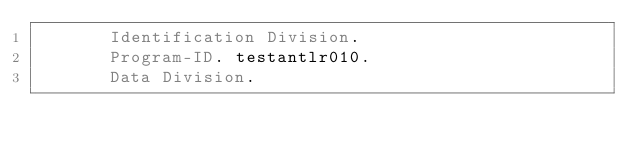<code> <loc_0><loc_0><loc_500><loc_500><_COBOL_>       Identification Division.
       Program-ID. testantlr010.
       Data Division.</code> 